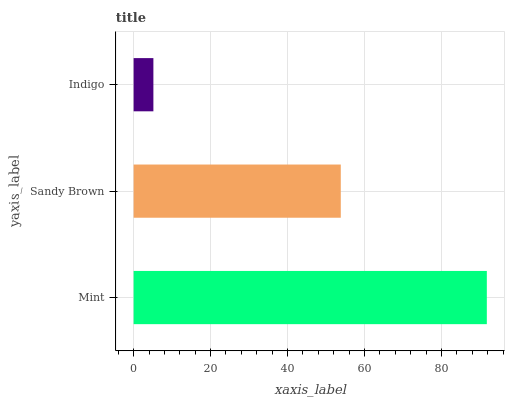Is Indigo the minimum?
Answer yes or no. Yes. Is Mint the maximum?
Answer yes or no. Yes. Is Sandy Brown the minimum?
Answer yes or no. No. Is Sandy Brown the maximum?
Answer yes or no. No. Is Mint greater than Sandy Brown?
Answer yes or no. Yes. Is Sandy Brown less than Mint?
Answer yes or no. Yes. Is Sandy Brown greater than Mint?
Answer yes or no. No. Is Mint less than Sandy Brown?
Answer yes or no. No. Is Sandy Brown the high median?
Answer yes or no. Yes. Is Sandy Brown the low median?
Answer yes or no. Yes. Is Indigo the high median?
Answer yes or no. No. Is Indigo the low median?
Answer yes or no. No. 